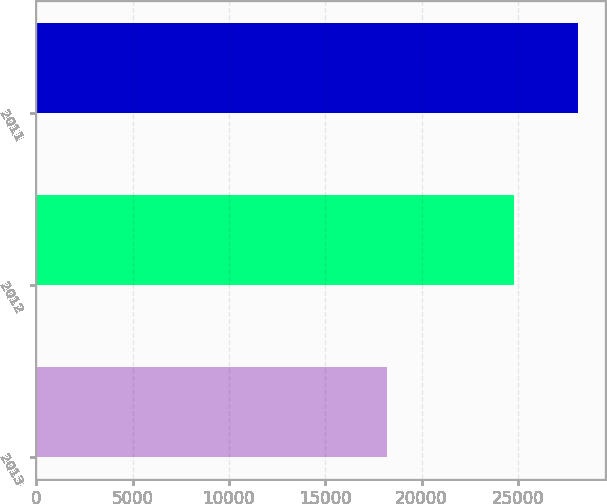Convert chart. <chart><loc_0><loc_0><loc_500><loc_500><bar_chart><fcel>2013<fcel>2012<fcel>2011<nl><fcel>18188<fcel>24823<fcel>28132<nl></chart> 